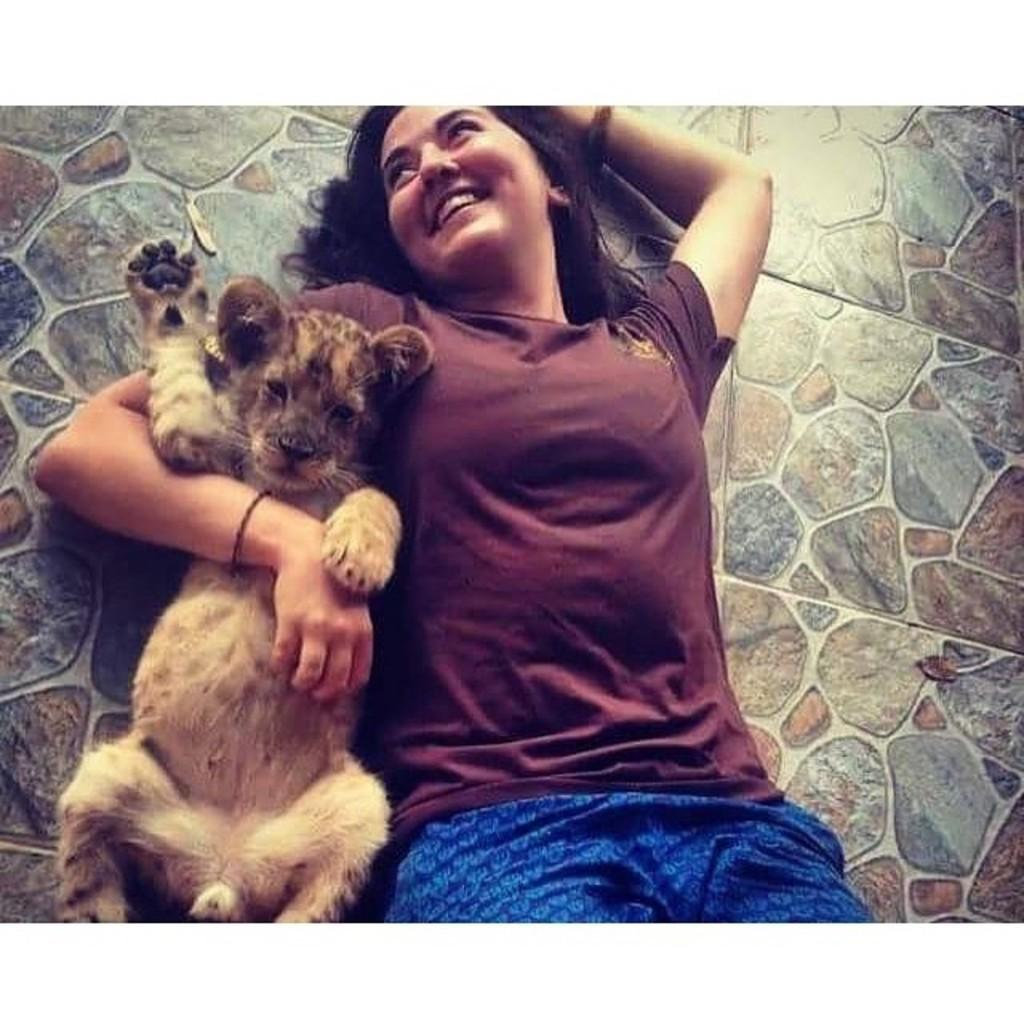Who is present in the image? There is a woman in the image. What is the woman wearing? The woman is wearing a brown t-shirt. What is the woman holding in the image? The woman is holding a cat. What can be seen in the background of the image? There is a wall in the background of the image. What type of bean is being used to paint the quartz in the image? There is no bean, paint, or quartz present in the image. 